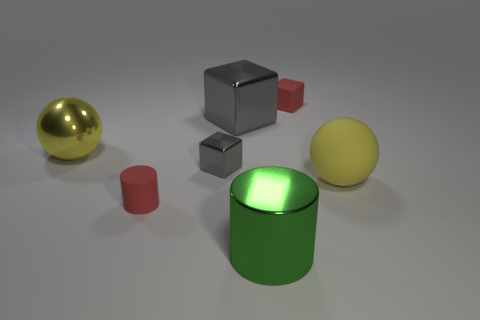Add 3 red rubber objects. How many objects exist? 10 Subtract all blue cubes. Subtract all blue balls. How many cubes are left? 3 Subtract all balls. How many objects are left? 5 Add 3 big green rubber things. How many big green rubber things exist? 3 Subtract 0 blue spheres. How many objects are left? 7 Subtract all yellow matte things. Subtract all large yellow rubber balls. How many objects are left? 5 Add 1 tiny metallic cubes. How many tiny metallic cubes are left? 2 